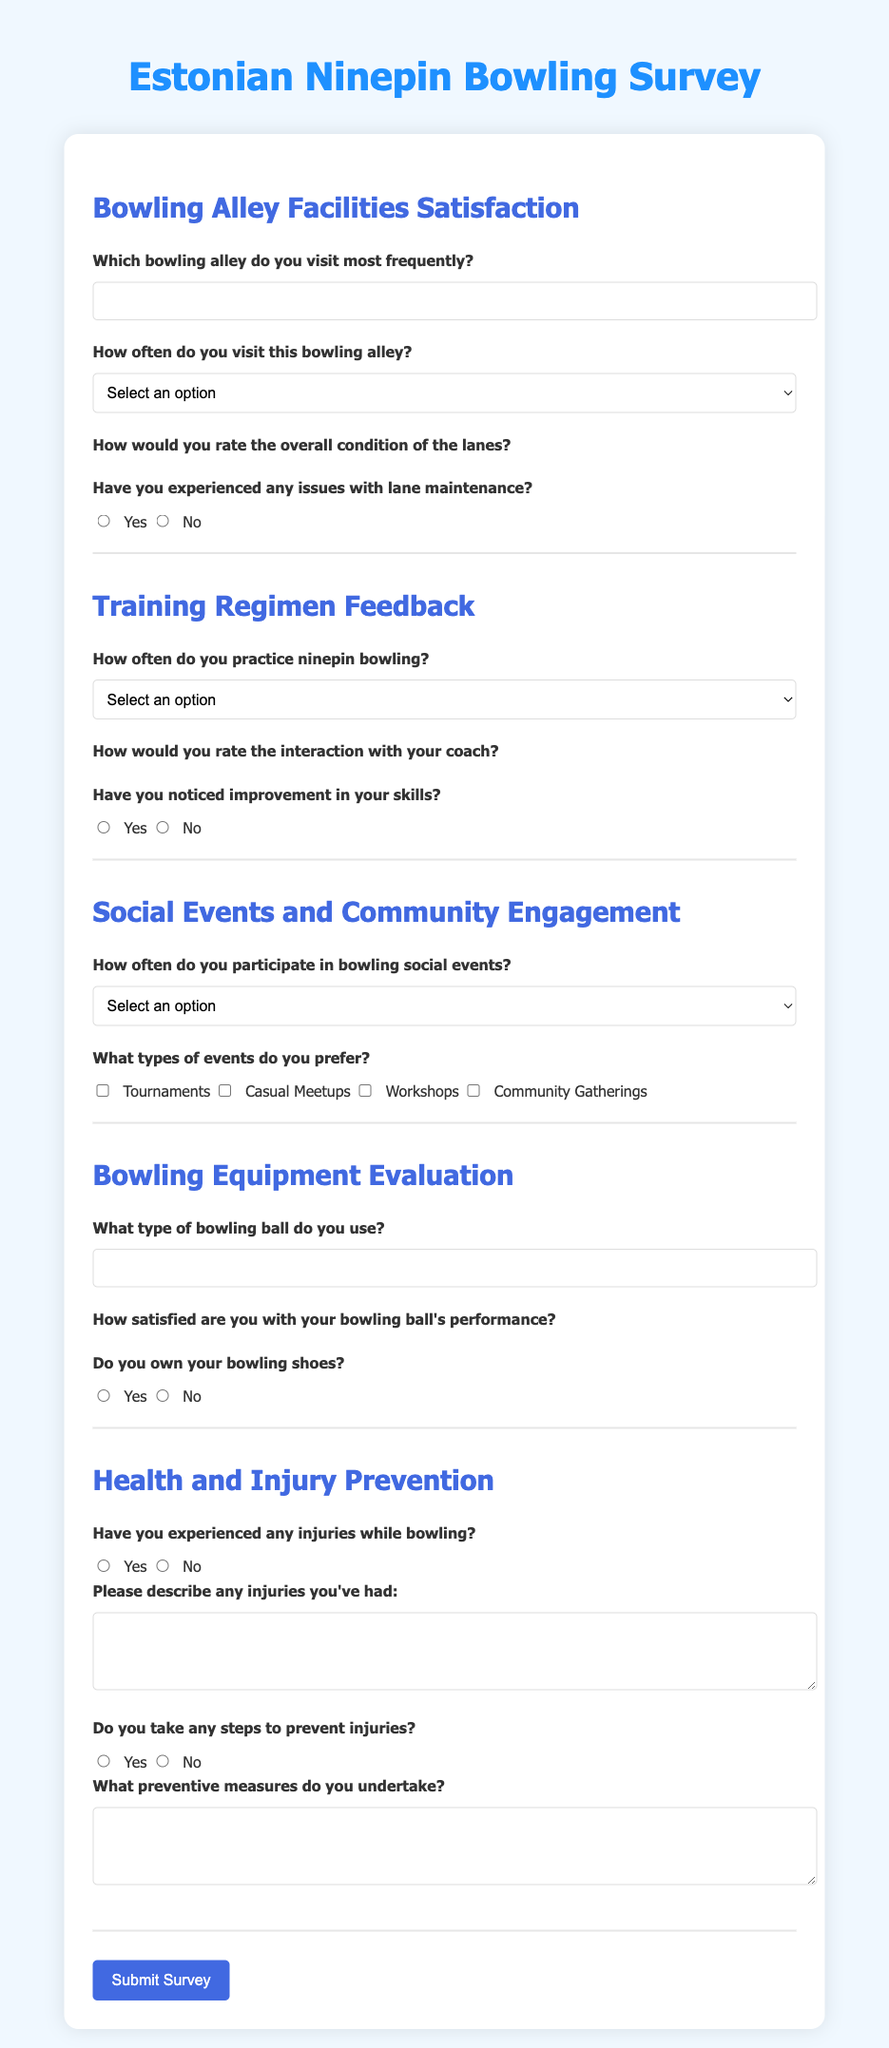What is the title of the survey? The title is found at the top of the document, indicating its focus on ninepin bowling.
Answer: Estonian Ninepin Bowling Survey What type of feedback does the second section seek? The second section specifically asks about training practices and interactions with coaches regarding skill improvement.
Answer: Training Regimen Feedback How many frequency options are provided in the "Bowling Alley Facilities Satisfaction" section? The number of options is calculated by counting the selectable frequency choices listed in the section.
Answer: Four How can participants indicate their satisfaction with bowling ball performance? Participants can indicate their satisfaction using a rating system that involves selecting stars.
Answer: Star rating What important information does the "Health and Injury Prevention" section request? The section requires information about past injuries and preventive measures related to bowling.
Answer: Injury descriptions and prevention measures 